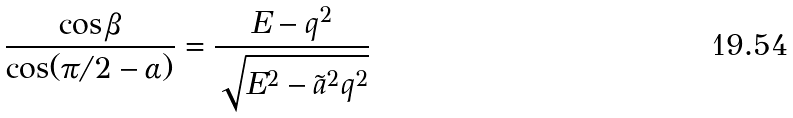<formula> <loc_0><loc_0><loc_500><loc_500>\frac { \cos \beta } { \cos ( \pi / 2 - \alpha ) } = \frac { E - q ^ { 2 } } { \sqrt { E ^ { 2 } - \tilde { a } ^ { 2 } q ^ { 2 } } }</formula> 